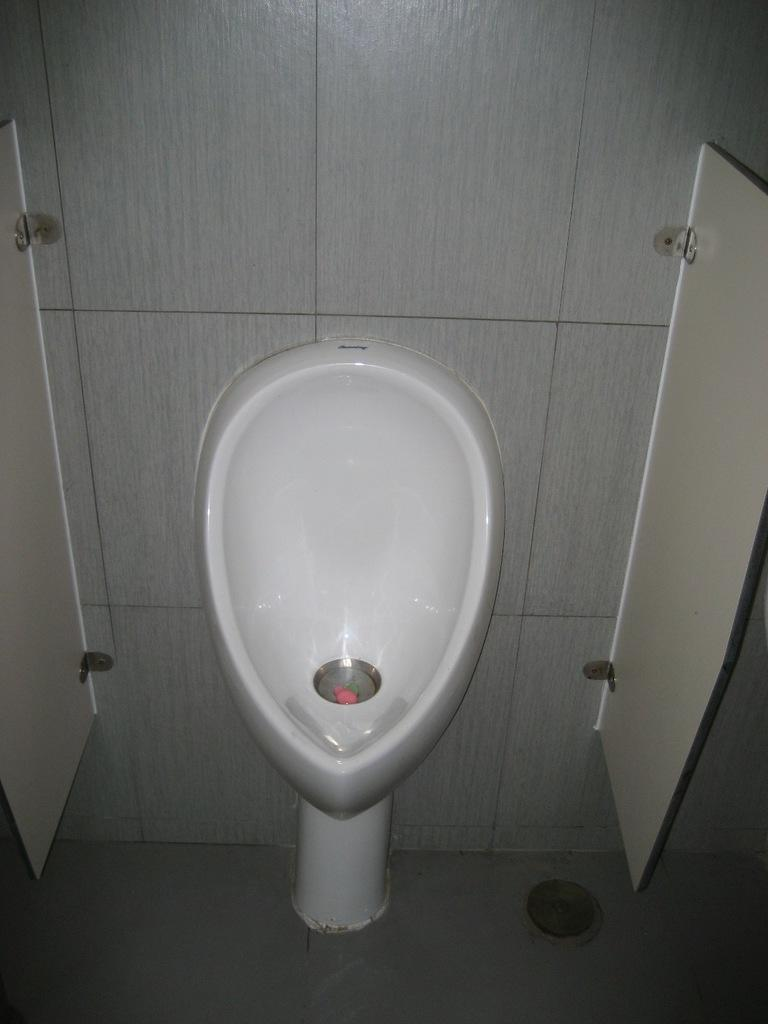What type of flooring is visible in the image? There are white color tiles in the image. What type of toilet can be seen in the image? There is a western toilet in the image. What type of animal can be seen in the middle of the image? There are no animals present in the image. What discovery was made in the image? There is no indication of a discovery in the image; it simply shows white color tiles and a western toilet. 